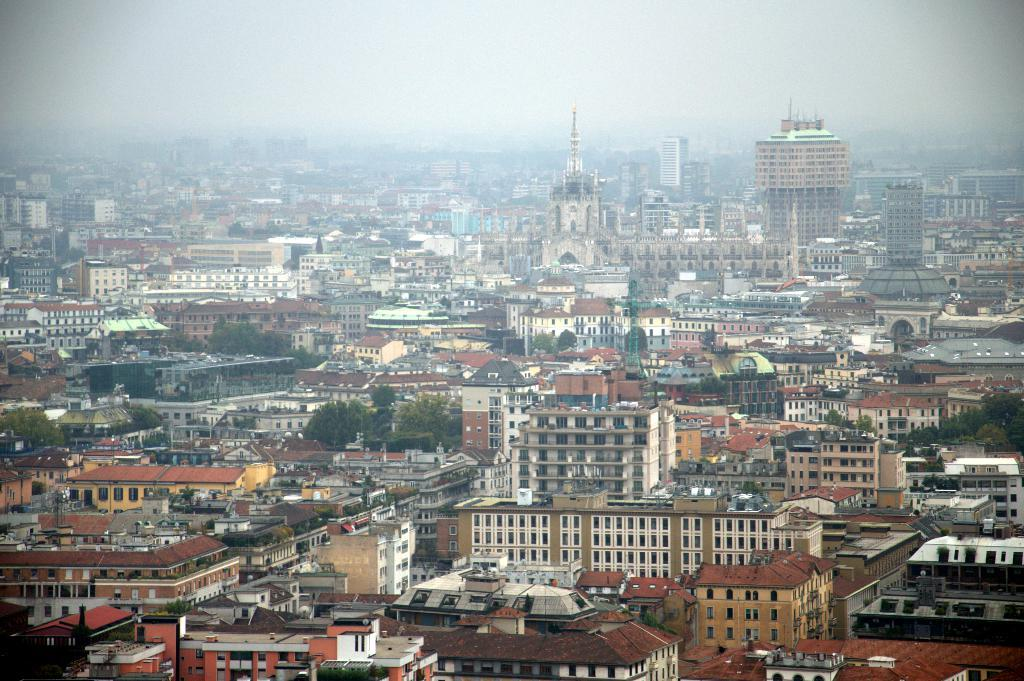What type of location is shown in the image? The image depicts a city. What structures can be seen in the city? There are buildings in the image. Are there any natural elements present in the city? Yes, there are trees in the image. What is visible at the top of the image? The sky is visible at the top of the image. Can you read the letter that is being handed to the friend in the image? There is no letter or friend present in the image; it depicts a city with buildings, trees, and a visible sky. 